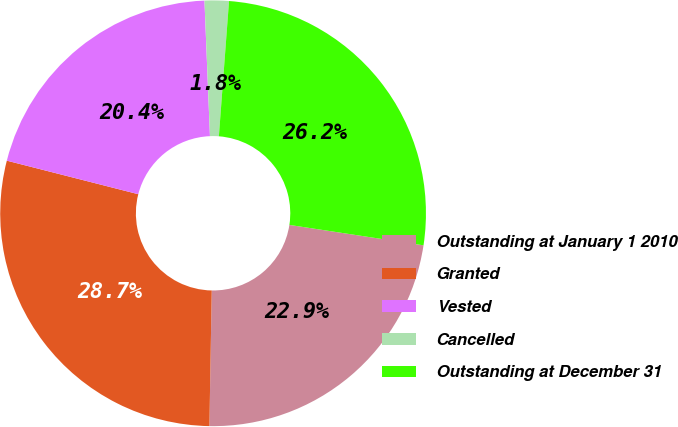Convert chart to OTSL. <chart><loc_0><loc_0><loc_500><loc_500><pie_chart><fcel>Outstanding at January 1 2010<fcel>Granted<fcel>Vested<fcel>Cancelled<fcel>Outstanding at December 31<nl><fcel>22.87%<fcel>28.7%<fcel>20.38%<fcel>1.84%<fcel>26.21%<nl></chart> 